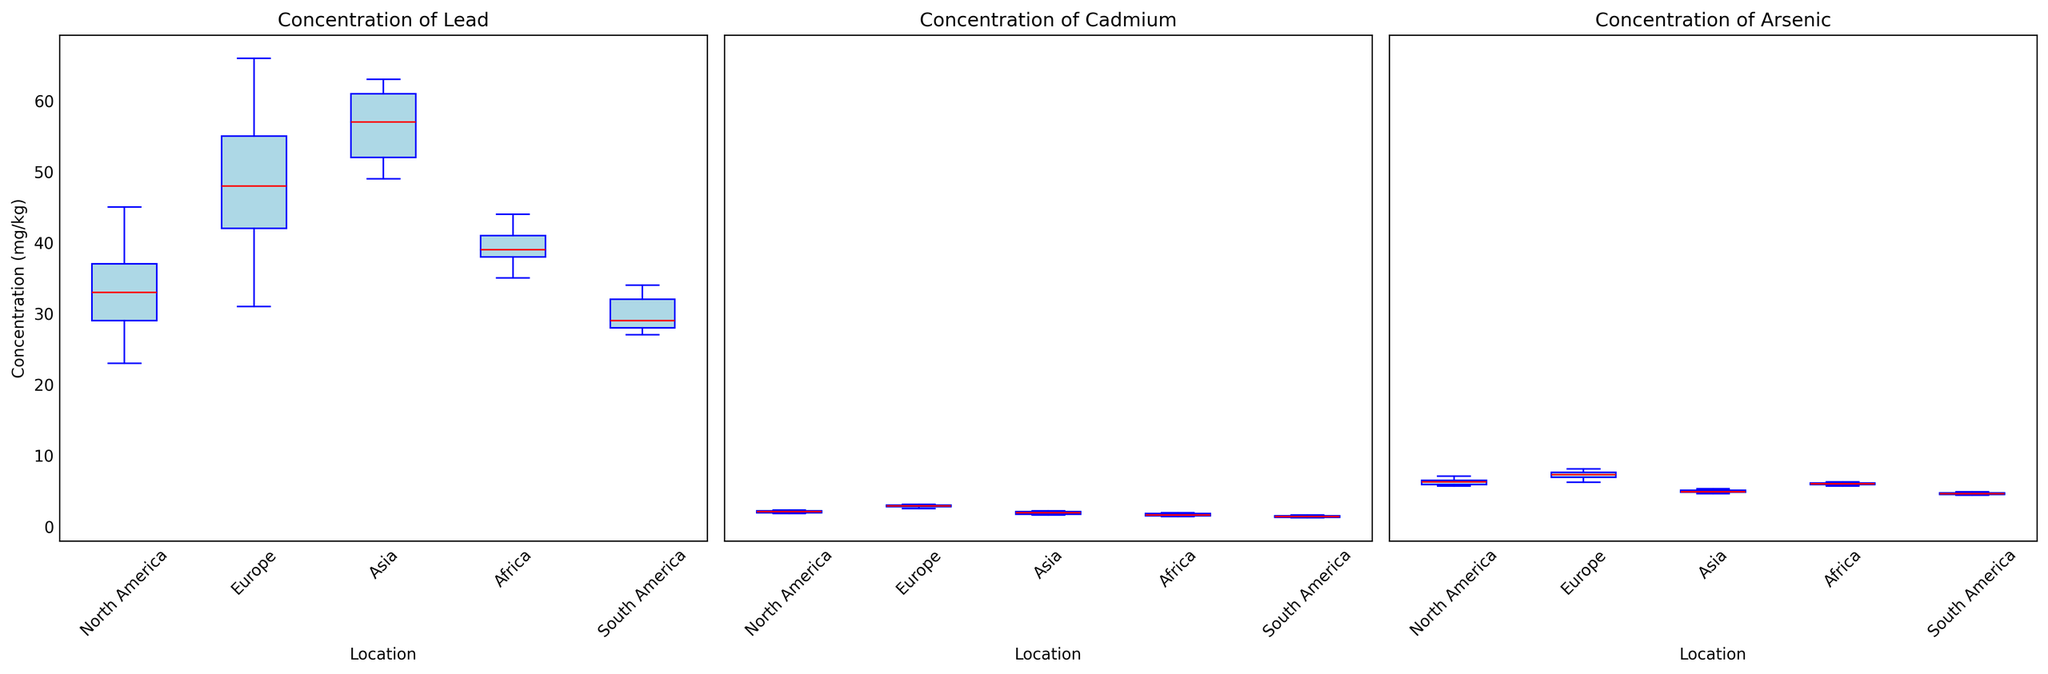What is the median concentration of lead in Europe? To find the median concentration of lead in Europe, look at the data distribution on the box plot for Europe under the Lead category. The median is the red line inside the box.
Answer: 48 Which geographical area has the highest median concentration of cadmium? Compare the red median lines inside the box plots for cadmium across all geographical areas. The highest median line indicates the highest median concentration.
Answer: Europe Does North America or Asia have a wider concentration range for arsenic? Evaluate the length of the whiskers (from the lowest to the highest value) for arsenic in both North America and Asia. The area with the longer whiskers (box plus lines) has a wider range.
Answer: North America How does the median concentration of arsenic in South America compare to that in Africa? Look at the red median lines inside the box plots for arsenic in both South America and Africa. Compare the heights of these two lines to determine the relationship.
Answer: Lower Which metal shows the least variability in concentration in North America? Check the length of the boxes and whiskers for each metal in North America to determine which one is the shortest, indicating the least variability.
Answer: Cadmium Are there any geographical areas where the concentrations of any metals are very similar? Identify if there are any pairs of locations where the median lines (red) and boxes are nearly aligned for a specific metal, indicating similar concentration distributions.
Answer: Yes, South America and Africa for cadmium are very similar What is the interquartile range (IQR) for lead concentration in Asia? The IQR is the range between the first quartile (bottom of the box) and third quartile (top of the box) in the box plot for lead in Asia. Measure the distance between these two points on the scale.
Answer: 12 (63-49) Which geographical area has the smallest median concentration of arsenic? Assess the red median lines inside the box plots for arsenic across all geographical areas. The smallest median line indicates the smallest median concentration.
Answer: South America Compare the upper whisker limit of cadmium concentration in Europe to that in Africa. Examine the length of the whiskers extending upwards (indicating the maximum values) for cadmium in both Europe and Africa. Compare the height of these upper whisker limits.
Answer: Higher in Europe Is there a noticeable outlier in any of the metal concentrations? Look for any data points that are separate from the main box and whiskers for each metal in each geographical area. Outliers often appear as individual points above or below the whiskers.
Answer: No noticeable outliers 